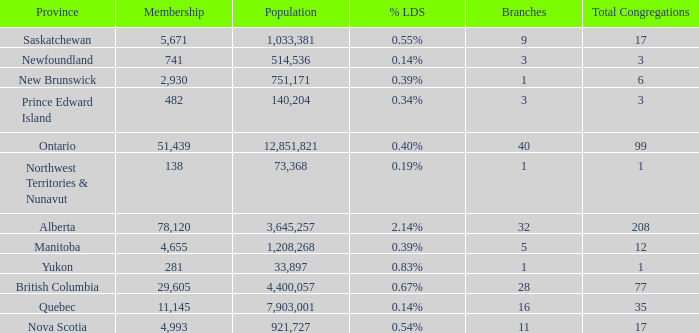What's the sum of the total congregation in the manitoba province with less than 1,208,268 population? None. 